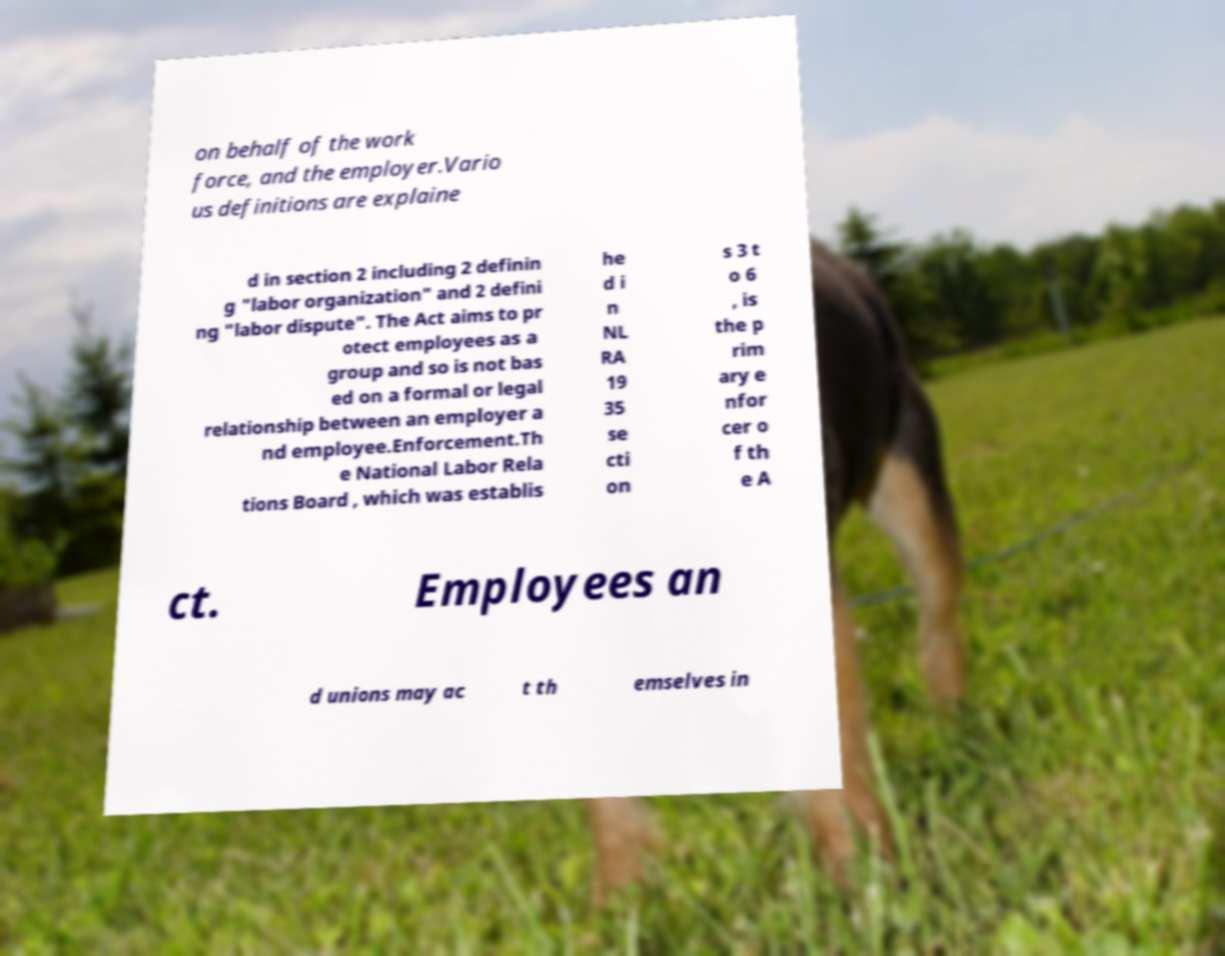Please identify and transcribe the text found in this image. on behalf of the work force, and the employer.Vario us definitions are explaine d in section 2 including 2 definin g "labor organization" and 2 defini ng "labor dispute". The Act aims to pr otect employees as a group and so is not bas ed on a formal or legal relationship between an employer a nd employee.Enforcement.Th e National Labor Rela tions Board , which was establis he d i n NL RA 19 35 se cti on s 3 t o 6 , is the p rim ary e nfor cer o f th e A ct. Employees an d unions may ac t th emselves in 